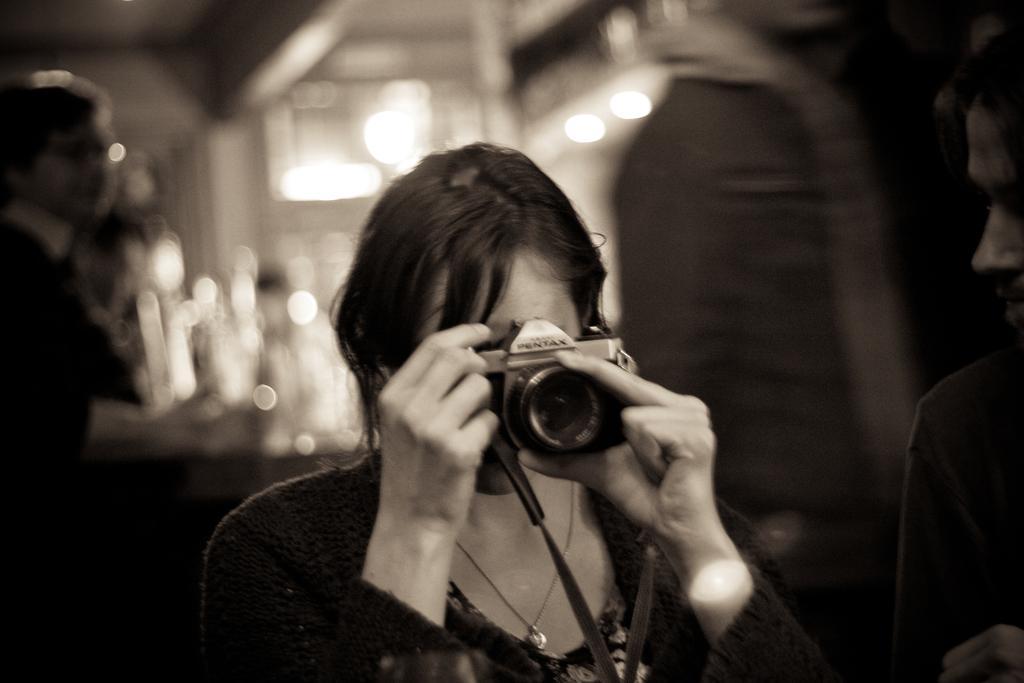Could you give a brief overview of what you see in this image? In this picture there is a lady who is standing at the center of the image, by holding a camera in her hands, there is a door at the right side of the image and there are other people around the area of the image. 